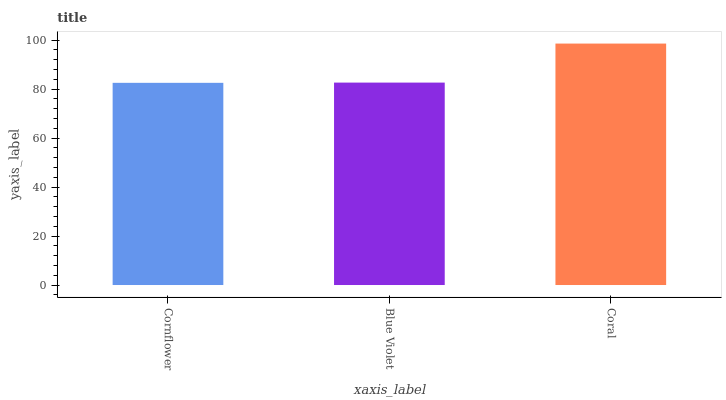Is Cornflower the minimum?
Answer yes or no. Yes. Is Coral the maximum?
Answer yes or no. Yes. Is Blue Violet the minimum?
Answer yes or no. No. Is Blue Violet the maximum?
Answer yes or no. No. Is Blue Violet greater than Cornflower?
Answer yes or no. Yes. Is Cornflower less than Blue Violet?
Answer yes or no. Yes. Is Cornflower greater than Blue Violet?
Answer yes or no. No. Is Blue Violet less than Cornflower?
Answer yes or no. No. Is Blue Violet the high median?
Answer yes or no. Yes. Is Blue Violet the low median?
Answer yes or no. Yes. Is Coral the high median?
Answer yes or no. No. Is Coral the low median?
Answer yes or no. No. 